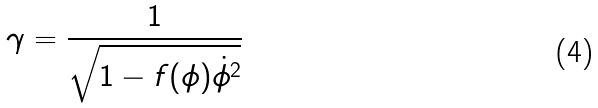Convert formula to latex. <formula><loc_0><loc_0><loc_500><loc_500>\gamma = \frac { 1 } { \sqrt { 1 - f ( \phi ) \dot { \phi } ^ { 2 } } }</formula> 